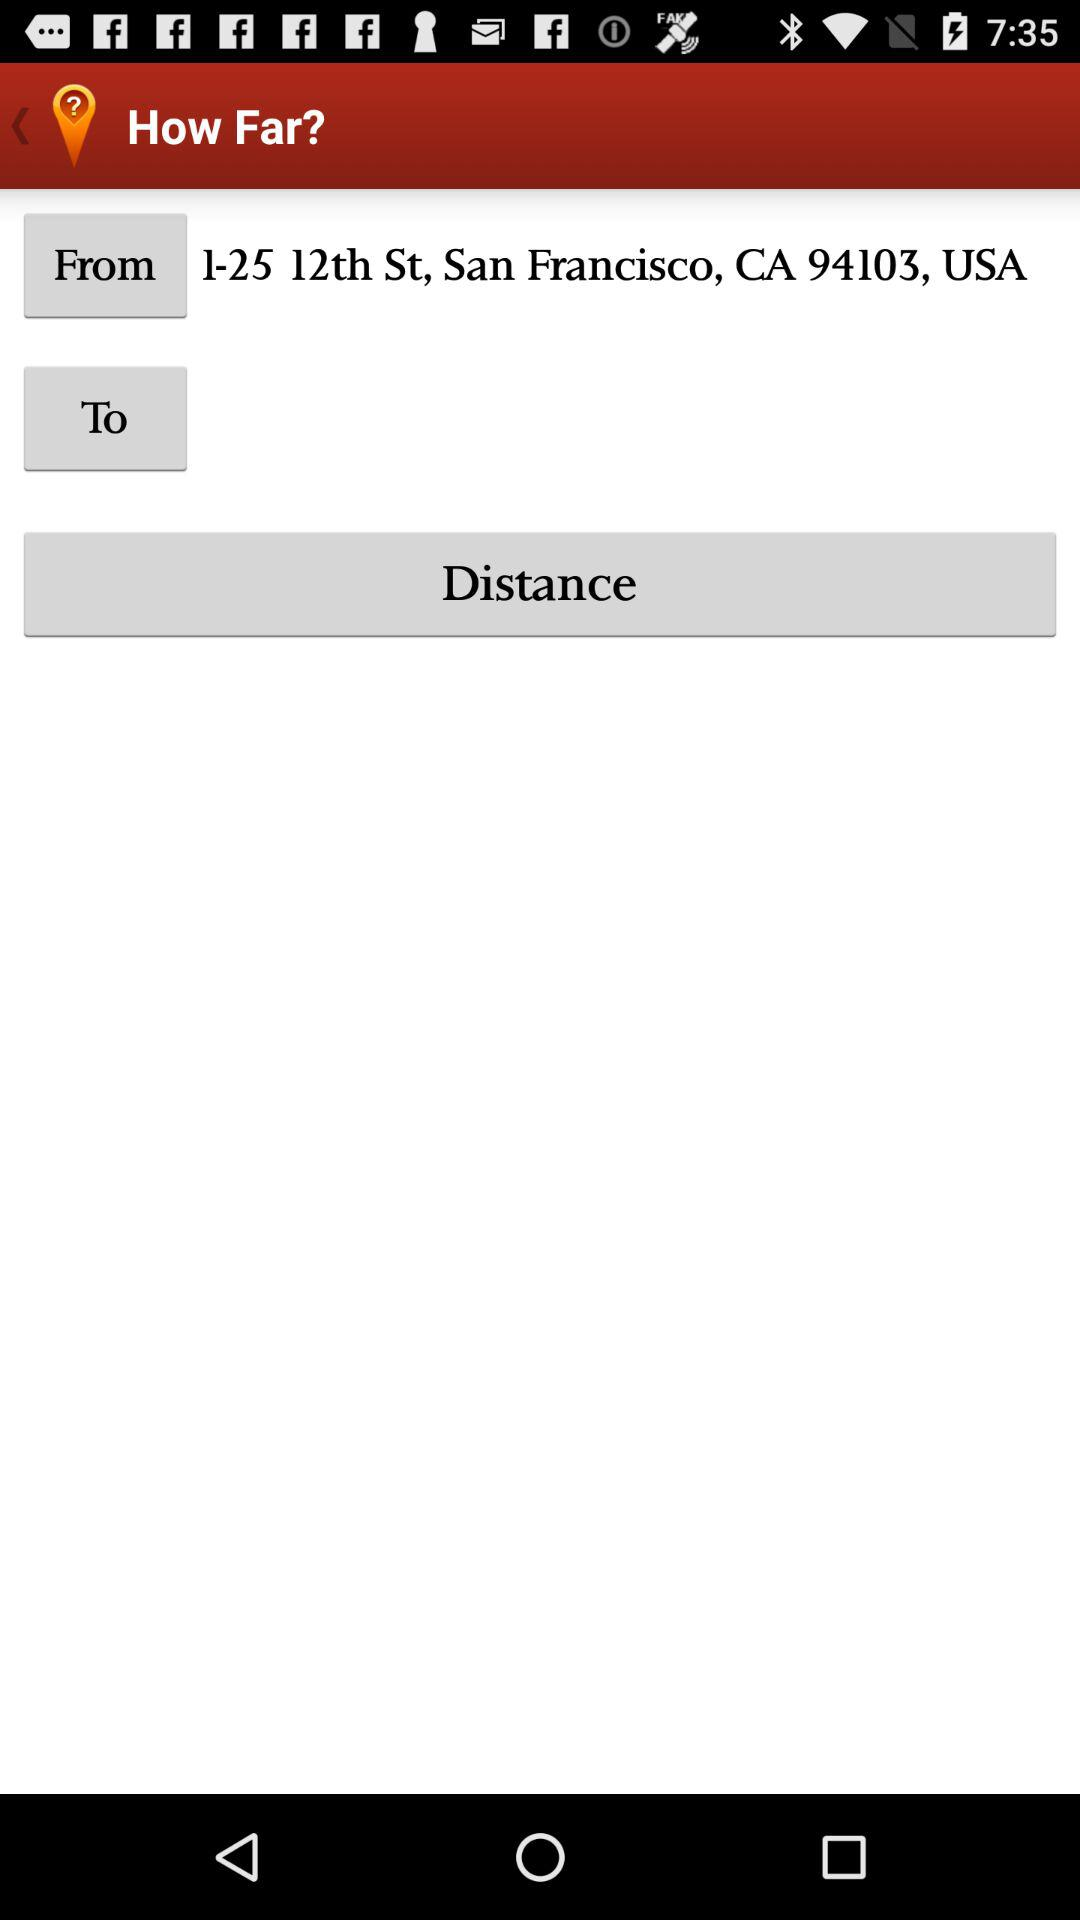What is the entered location in "From"? The entered location in "From" is 1-25 12th St, San Francisco, CA 94103, USA. 